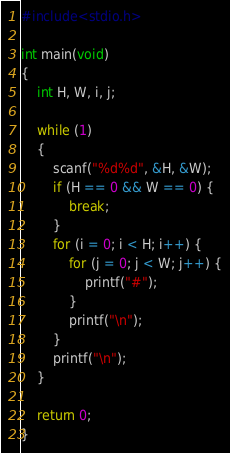<code> <loc_0><loc_0><loc_500><loc_500><_C_>#include<stdio.h>

int main(void)
{
	int H, W, i, j;

	while (1)
	{
		scanf("%d%d", &H, &W);
		if (H == 0 && W == 0) {
			break;
		}
		for (i = 0; i < H; i++) {
			for (j = 0; j < W; j++) {
				printf("#");
			}
			printf("\n");
		}
		printf("\n");
	}
	
	return 0;
}
</code> 